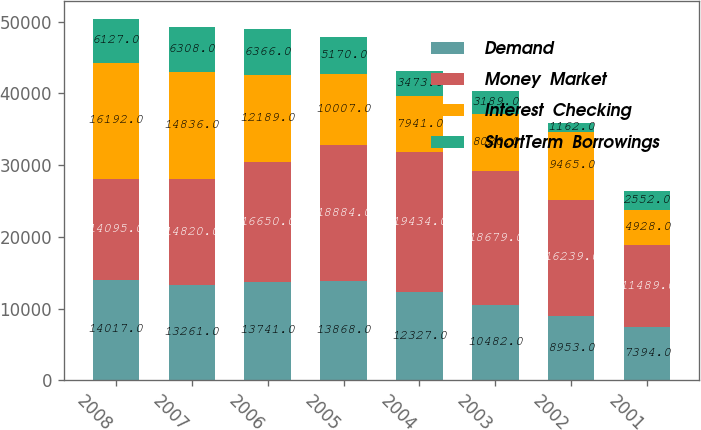Convert chart to OTSL. <chart><loc_0><loc_0><loc_500><loc_500><stacked_bar_chart><ecel><fcel>2008<fcel>2007<fcel>2006<fcel>2005<fcel>2004<fcel>2003<fcel>2002<fcel>2001<nl><fcel>Demand<fcel>14017<fcel>13261<fcel>13741<fcel>13868<fcel>12327<fcel>10482<fcel>8953<fcel>7394<nl><fcel>Money  Market<fcel>14095<fcel>14820<fcel>16650<fcel>18884<fcel>19434<fcel>18679<fcel>16239<fcel>11489<nl><fcel>Interest  Checking<fcel>16192<fcel>14836<fcel>12189<fcel>10007<fcel>7941<fcel>8020<fcel>9465<fcel>4928<nl><fcel>ShortTerm  Borrowings<fcel>6127<fcel>6308<fcel>6366<fcel>5170<fcel>3473<fcel>3189<fcel>1162<fcel>2552<nl></chart> 